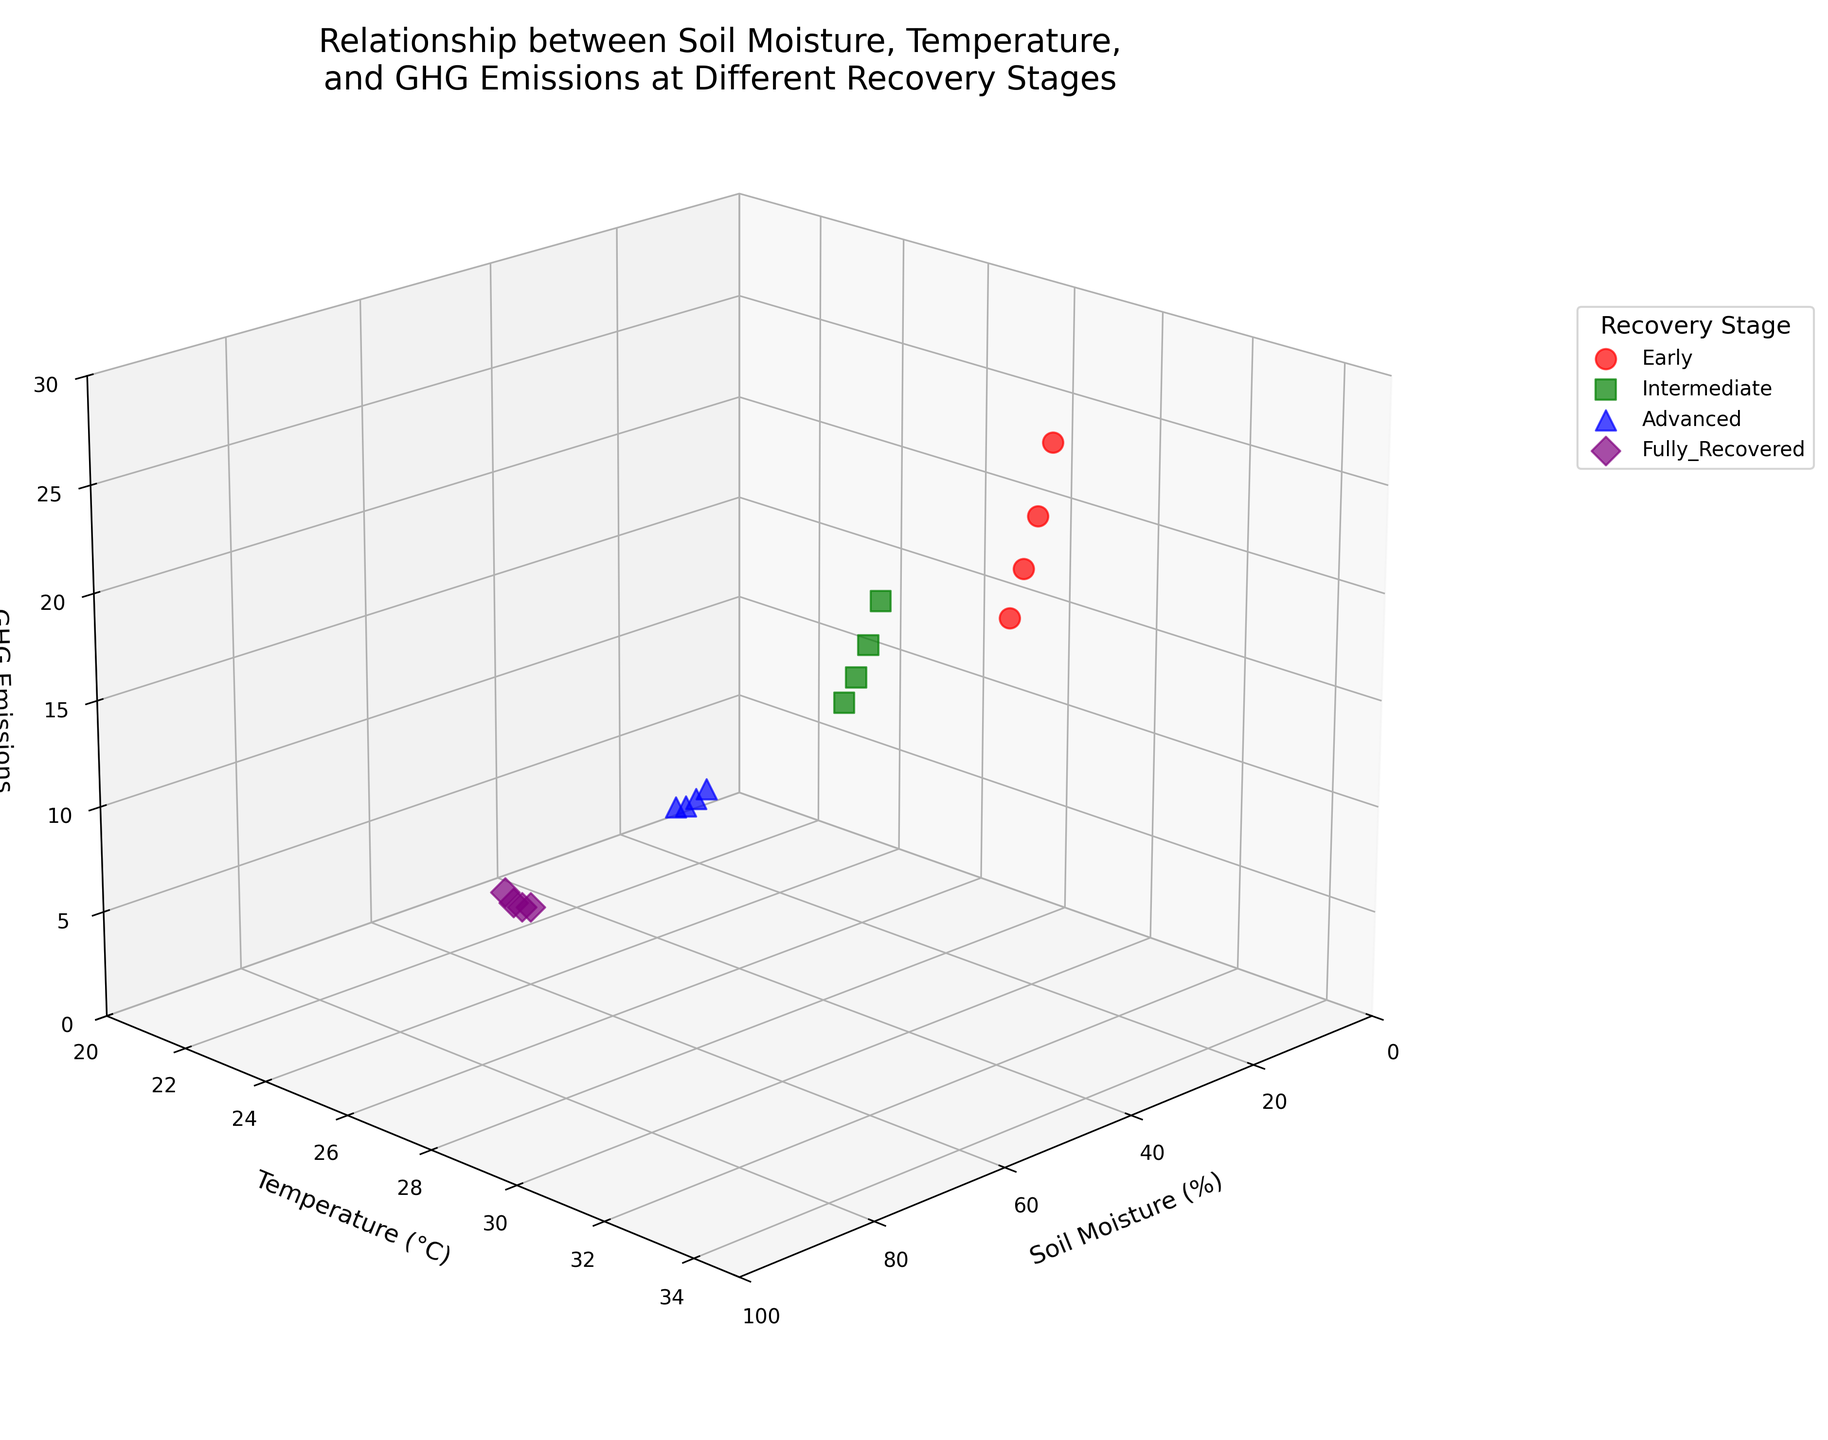What is the title of the figure? The title of a figure is usually located at the top and describes what the figure is about. In this case, it states "Relationship between Soil Moisture, Temperature, and GHG Emissions at Different Recovery Stages".
Answer: Relationship between Soil Moisture, Temperature, and GHG Emissions at Different Recovery Stages How many recovery stages are represented in the figure? There are four different colors and markers representing the recovery stages which are mentioned in the legend. These are 'Early', 'Intermediate', 'Advanced', and 'Fully_Recovered'.
Answer: Four Which recovery stage has the highest GHG emissions? By observing the vertical axis (GHG Emissions) and identifying the highest value point, it is within the 'Early' stage which uses the red 'o' markers.
Answer: Early What are the ranges for soil moisture and temperature axes? The soil moisture (horizontal axis) ranges from 0 to 100%, and the temperature (middle axis) ranges from 20 to 35°C. The ranges can be identified based on the axis limits.
Answer: Soil Moisture: 0-100%, Temperature: 20-35°C Which recovery stage generally has the lowest GHG emissions? Looking at the vertical axis and identifying the points with lowest values, they are mostly within the 'Fully_Recovered' stage which uses the purple 'D' markers.
Answer: Fully_Recovered Compare the GHG emissions for early and intermediate recovery stages at 28°C. Which one is higher? Identify the points for both 'Early' (red 'o' markers) and 'Intermediate' (green 's' markers) at 28°C. 'Early' emissions at 28°C are 15.2 gCO2e/m²/day, and 'Intermediate' emissions are 14.9 gCO2e/m²/day, so 'Early' is higher.
Answer: Early What trend can be observed between soil moisture and GHG emissions in the 'Advanced' recovery stage? In the 'Advanced' stage (blue '^' markers), as soil moisture increases, GHG emissions initially increase then decrease with some fluctuations.
Answer: Increase then decrease At 25% soil moisture, how do temperatures compare between 'Early' and 'Intermediate' recovery stages? Locate the points at 25% soil moisture for both 'Early' (31°C) and 'Intermediate' (27°C) stages. 'Early' has a higher temperature than 'Intermediate'.
Answer: Early > Intermediate Which recovery stage shows the greatest range in GHG emissions? The 'Early' stage (red 'o') displays GHG emissions ranging from around 15.2 to 26.8 gCO2e/m²/day, which is a greater range compared to other stages.
Answer: Early Describe the view angle of the 3D plot. The view angle is set to an elevation of 20° and an azimuth of 45°, which can be inferred from the depth and perspective presented in the figure.
Answer: Elevation: 20°, Azimuth: 45° 